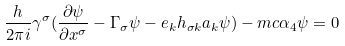Convert formula to latex. <formula><loc_0><loc_0><loc_500><loc_500>\frac { h } { 2 \pi i } \gamma ^ { \sigma } ( \frac { \partial \psi } { \partial x ^ { \sigma } } - \Gamma _ { \sigma } \psi - e _ { k } h _ { \sigma k } a _ { k } \psi ) - m c \alpha _ { 4 } \psi = 0</formula> 